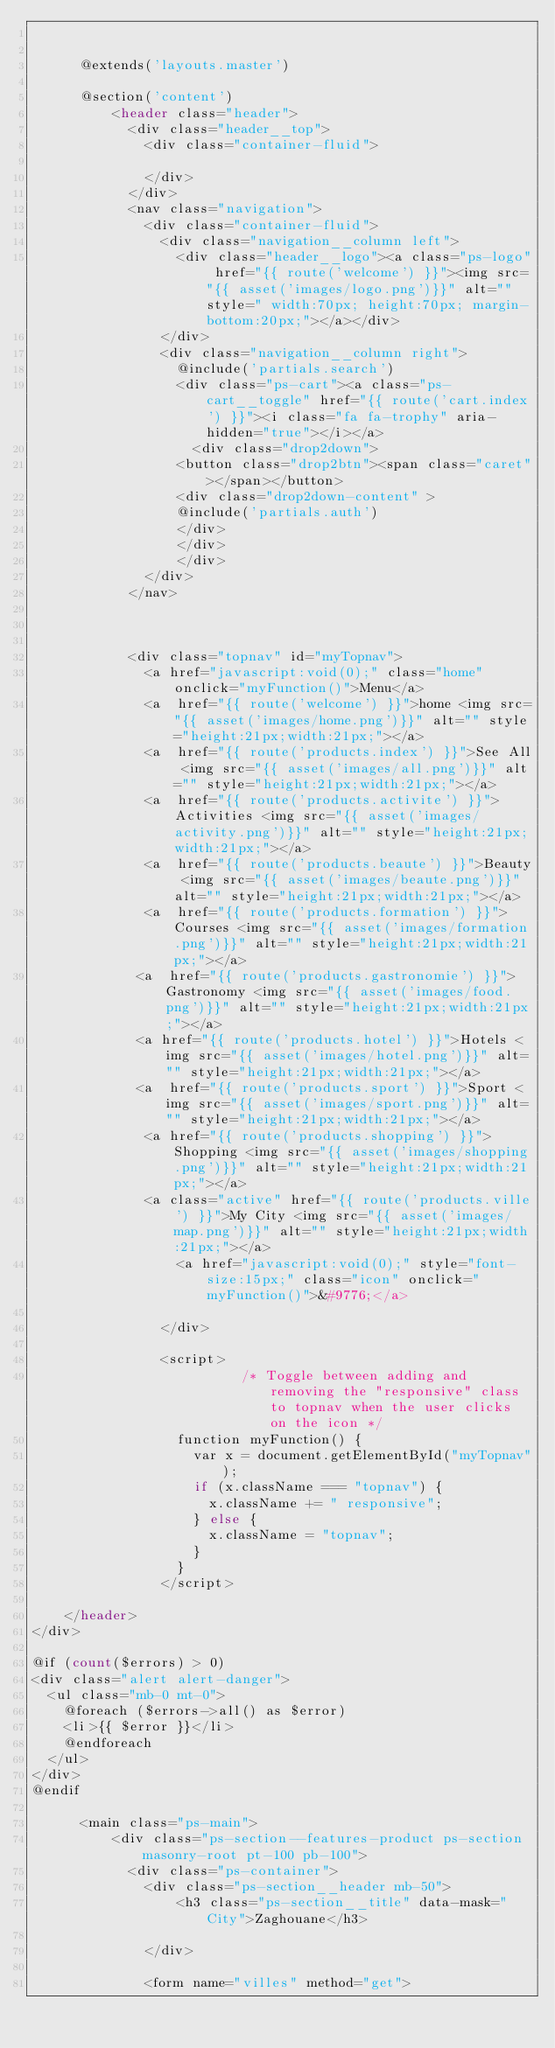<code> <loc_0><loc_0><loc_500><loc_500><_PHP_>      
      
      @extends('layouts.master')
      
      @section('content')
          <header class="header">
            <div class="header__top">
              <div class="container-fluid">
             
              </div>
            </div>
            <nav class="navigation">
              <div class="container-fluid">
                <div class="navigation__column left">
                  <div class="header__logo"><a class="ps-logo" href="{{ route('welcome') }}"><img src="{{ asset('images/logo.png')}}" alt="" style=" width:70px; height:70px; margin-bottom:20px;"></a></div>
                </div>
                <div class="navigation__column right">
                  @include('partials.search')
                  <div class="ps-cart"><a class="ps-cart__toggle" href="{{ route('cart.index') }}"><i class="fa fa-trophy" aria-hidden="true"></i></a>
                    <div class="drop2down">
                  <button class="drop2btn"><span class="caret"></span></button>
                  <div class="drop2down-content" >
                  @include('partials.auth')
                  </div>
                  </div>
                  </div>
              </div>
            </nav>
      
      
      
            <div class="topnav" id="myTopnav">
              <a href="javascript:void(0);" class="home" onclick="myFunction()">Menu</a>
              <a  href="{{ route('welcome') }}">home <img src="{{ asset('images/home.png')}}" alt="" style="height:21px;width:21px;"></a>
              <a  href="{{ route('products.index') }}">See All <img src="{{ asset('images/all.png')}}" alt="" style="height:21px;width:21px;"></a>
              <a  href="{{ route('products.activite') }}">Activities <img src="{{ asset('images/activity.png')}}" alt="" style="height:21px;width:21px;"></a>
              <a  href="{{ route('products.beaute') }}">Beauty <img src="{{ asset('images/beaute.png')}}" alt="" style="height:21px;width:21px;"></a>
              <a  href="{{ route('products.formation') }}">Courses <img src="{{ asset('images/formation.png')}}" alt="" style="height:21px;width:21px;"></a>
             <a  href="{{ route('products.gastronomie') }}">Gastronomy <img src="{{ asset('images/food.png')}}" alt="" style="height:21px;width:21px;"></a>
             <a href="{{ route('products.hotel') }}">Hotels <img src="{{ asset('images/hotel.png')}}" alt="" style="height:21px;width:21px;"></a>
             <a  href="{{ route('products.sport') }}">Sport <img src="{{ asset('images/sport.png')}}" alt="" style="height:21px;width:21px;"></a>
              <a href="{{ route('products.shopping') }}">Shopping <img src="{{ asset('images/shopping.png')}}" alt="" style="height:21px;width:21px;"></a>
              <a class="active" href="{{ route('products.ville') }}">My City <img src="{{ asset('images/map.png')}}" alt="" style="height:21px;width:21px;"></a>
                  <a href="javascript:void(0);" style="font-size:15px;" class="icon" onclick="myFunction()">&#9776;</a>
      
                </div>
                  
                <script>
                          /* Toggle between adding and removing the "responsive" class to topnav when the user clicks on the icon */
                  function myFunction() {
                    var x = document.getElementById("myTopnav");
                    if (x.className === "topnav") {
                      x.className += " responsive";
                    } else {
                      x.className = "topnav";
                    }
                  }
                </script>

    </header>
</div>

@if (count($errors) > 0)
<div class="alert alert-danger">
  <ul class="mb-0 mt-0">
    @foreach ($errors->all() as $error)
    <li>{{ $error }}</li>
    @endforeach
  </ul>
</div>
@endif

      <main class="ps-main">
          <div class="ps-section--features-product ps-section masonry-root pt-100 pb-100">
            <div class="ps-container">
              <div class="ps-section__header mb-50">
                  <h3 class="ps-section__title" data-mask="City">Zaghouane</h3>

              </div>

              <form name="villes" method="get">
</code> 